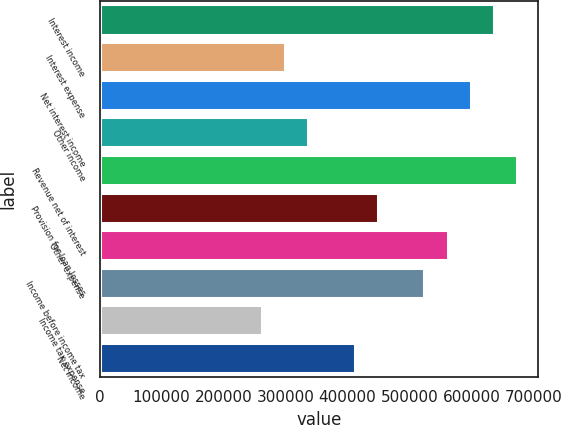Convert chart. <chart><loc_0><loc_0><loc_500><loc_500><bar_chart><fcel>Interest income<fcel>Interest expense<fcel>Net interest income<fcel>Other income<fcel>Revenue net of interest<fcel>Provision for loan losses<fcel>Other expense<fcel>Income before income tax<fcel>Income tax expense<fcel>Net income<nl><fcel>636523<fcel>299541<fcel>599081<fcel>336984<fcel>673966<fcel>449311<fcel>561638<fcel>524196<fcel>262099<fcel>411868<nl></chart> 